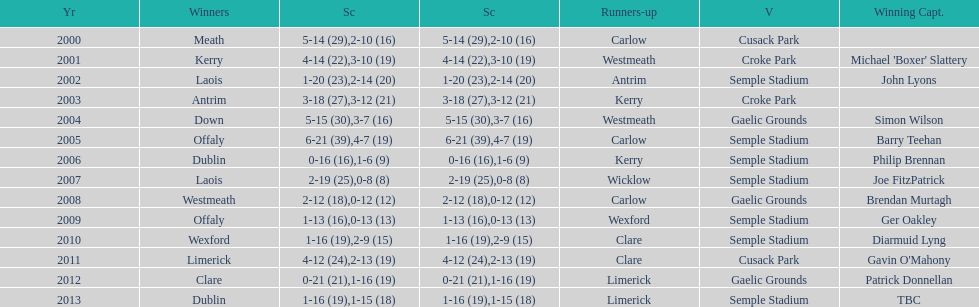Can you give me this table as a dict? {'header': ['Yr', 'Winners', 'Sc', 'Sc', 'Runners-up', 'V', 'Winning Capt.'], 'rows': [['2000', 'Meath', '5-14 (29)', '2-10 (16)', 'Carlow', 'Cusack Park', ''], ['2001', 'Kerry', '4-14 (22)', '3-10 (19)', 'Westmeath', 'Croke Park', "Michael 'Boxer' Slattery"], ['2002', 'Laois', '1-20 (23)', '2-14 (20)', 'Antrim', 'Semple Stadium', 'John Lyons'], ['2003', 'Antrim', '3-18 (27)', '3-12 (21)', 'Kerry', 'Croke Park', ''], ['2004', 'Down', '5-15 (30)', '3-7 (16)', 'Westmeath', 'Gaelic Grounds', 'Simon Wilson'], ['2005', 'Offaly', '6-21 (39)', '4-7 (19)', 'Carlow', 'Semple Stadium', 'Barry Teehan'], ['2006', 'Dublin', '0-16 (16)', '1-6 (9)', 'Kerry', 'Semple Stadium', 'Philip Brennan'], ['2007', 'Laois', '2-19 (25)', '0-8 (8)', 'Wicklow', 'Semple Stadium', 'Joe FitzPatrick'], ['2008', 'Westmeath', '2-12 (18)', '0-12 (12)', 'Carlow', 'Gaelic Grounds', 'Brendan Murtagh'], ['2009', 'Offaly', '1-13 (16)', '0-13 (13)', 'Wexford', 'Semple Stadium', 'Ger Oakley'], ['2010', 'Wexford', '1-16 (19)', '2-9 (15)', 'Clare', 'Semple Stadium', 'Diarmuid Lyng'], ['2011', 'Limerick', '4-12 (24)', '2-13 (19)', 'Clare', 'Cusack Park', "Gavin O'Mahony"], ['2012', 'Clare', '0-21 (21)', '1-16 (19)', 'Limerick', 'Gaelic Grounds', 'Patrick Donnellan'], ['2013', 'Dublin', '1-16 (19)', '1-15 (18)', 'Limerick', 'Semple Stadium', 'TBC']]} Who was the first winning captain? Michael 'Boxer' Slattery. 